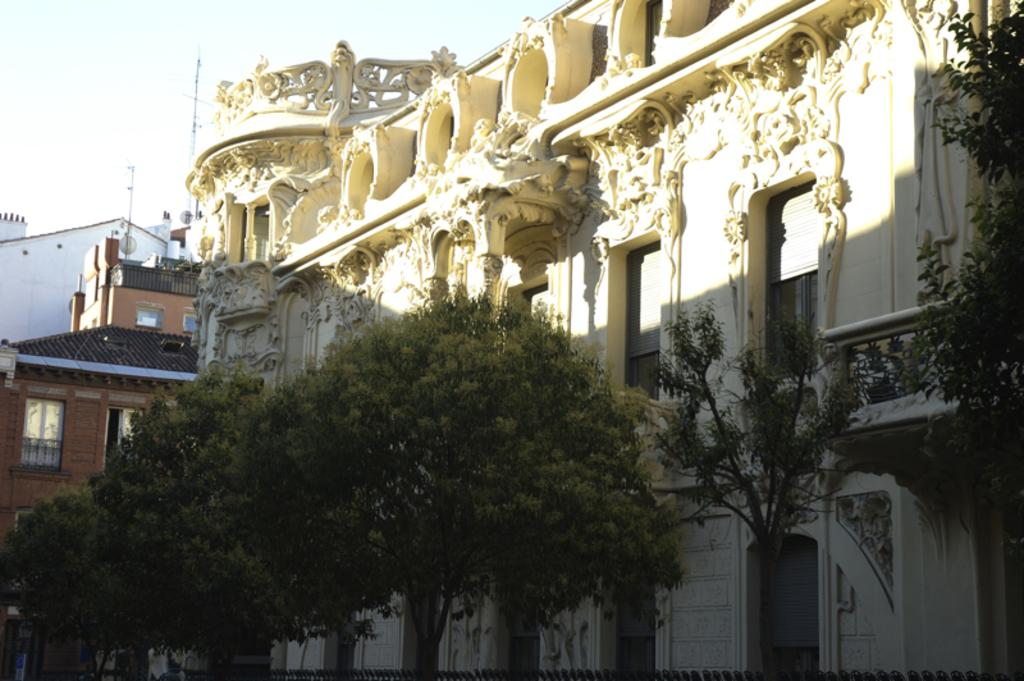What type of natural elements can be seen in the image? There are trees in the image. What type of man-made structures are present in the image? There are buildings with windows in the image. What type of barrier can be seen in the image? There is a fence in the image. What type of vertical structures are present in the image? There are poles in the image. Can you describe the background of the image? The sky is visible in the background of the image. What type of property is visible on the canvas in the image? There is no canvas or property present in the image. What type of heart-shaped object can be seen in the image? There is no heart-shaped object present in the image. 